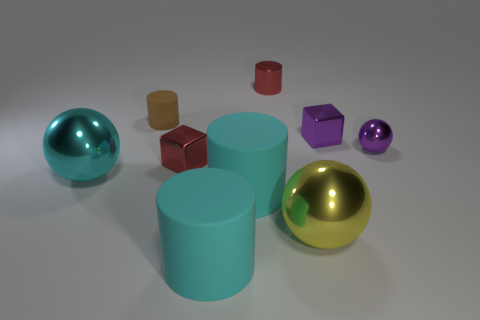Add 1 blue cubes. How many objects exist? 10 Subtract all small spheres. How many spheres are left? 2 Subtract 4 cylinders. How many cylinders are left? 0 Add 4 cyan matte things. How many cyan matte things are left? 6 Add 8 large brown cubes. How many large brown cubes exist? 8 Subtract all purple blocks. How many blocks are left? 1 Subtract 0 brown cubes. How many objects are left? 9 Subtract all balls. How many objects are left? 6 Subtract all yellow spheres. Subtract all yellow cylinders. How many spheres are left? 2 Subtract all cyan balls. How many green blocks are left? 0 